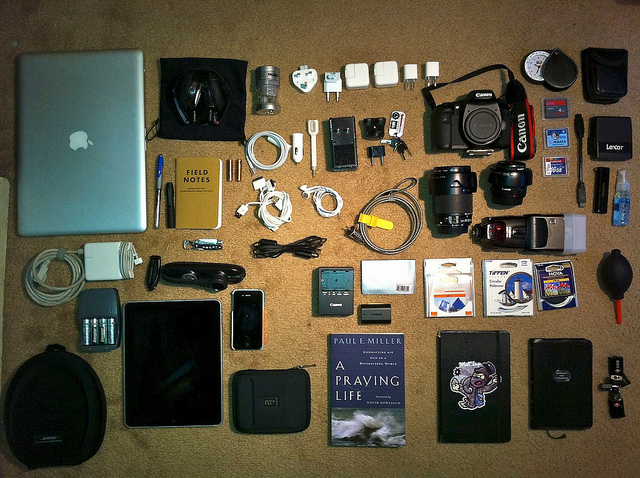<image>What is the red and black circle object on the left? I don't know what the red and black circle object on the left is. It could be a blower to remove dust, a camera lanyard, a case, a cord, a strap, or wires. What is the red and black circle object on the left? I am not sure what the red and black circle object on the left is. It can be seen as a blower to remove dust, camera lanyard, case, chord, or wires. 